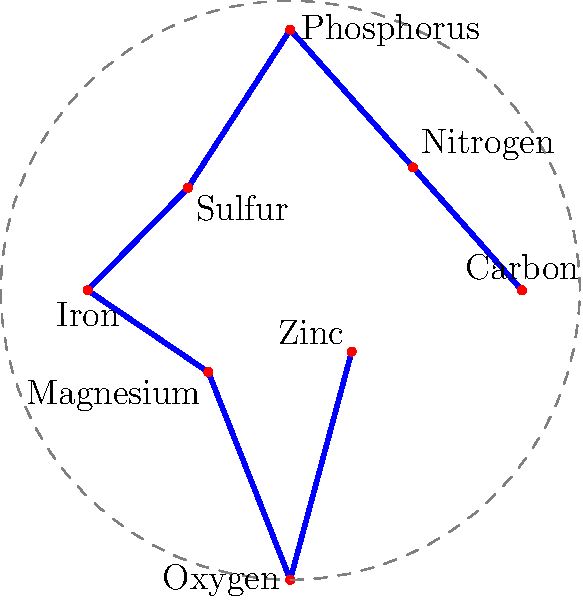The polar plot shows the relative growth rates of a bacterial species in different nutrient-limited environments. Which nutrient limitation results in the highest growth rate, and how does this compare to the growth rate under carbon limitation? To answer this question, we need to follow these steps:

1. Identify the highest point on the polar plot:
   The point furthest from the center represents the highest growth rate.
   
2. Determine which nutrient corresponds to this point:
   The highest point is on the left side of the plot, labeled "Oxygen".
   
3. Compare the oxygen-limited growth rate to carbon-limited growth rate:
   - Oxygen limitation (highest point): $r = 1.0$ (normalized units)
   - Carbon limitation (rightmost point): $r = 0.8$ (normalized units)
   
4. Calculate the relative difference:
   $\frac{1.0 - 0.8}{0.8} \times 100\% = 25\%$

Thus, the growth rate under oxygen limitation is 25% higher than under carbon limitation.
Answer: Oxygen; 25% higher than carbon-limited growth 